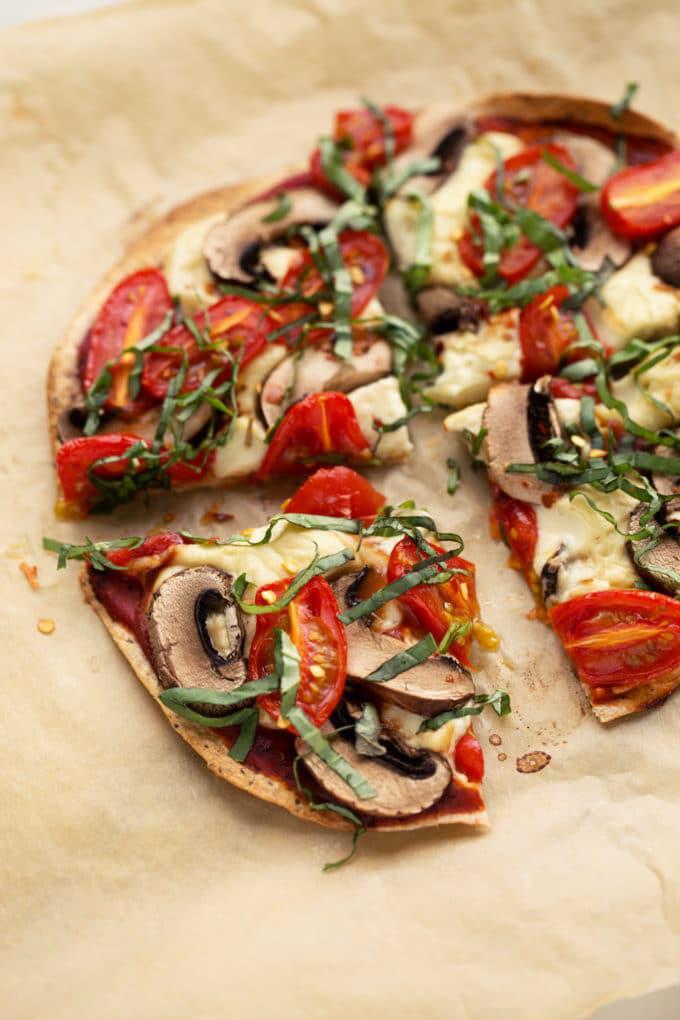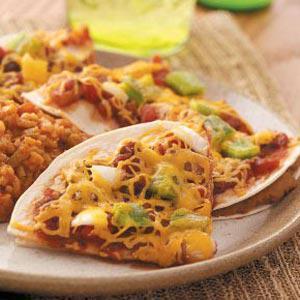The first image is the image on the left, the second image is the image on the right. Evaluate the accuracy of this statement regarding the images: "There at least two separate single slices of pizza sitting on a tray.". Is it true? Answer yes or no. Yes. 